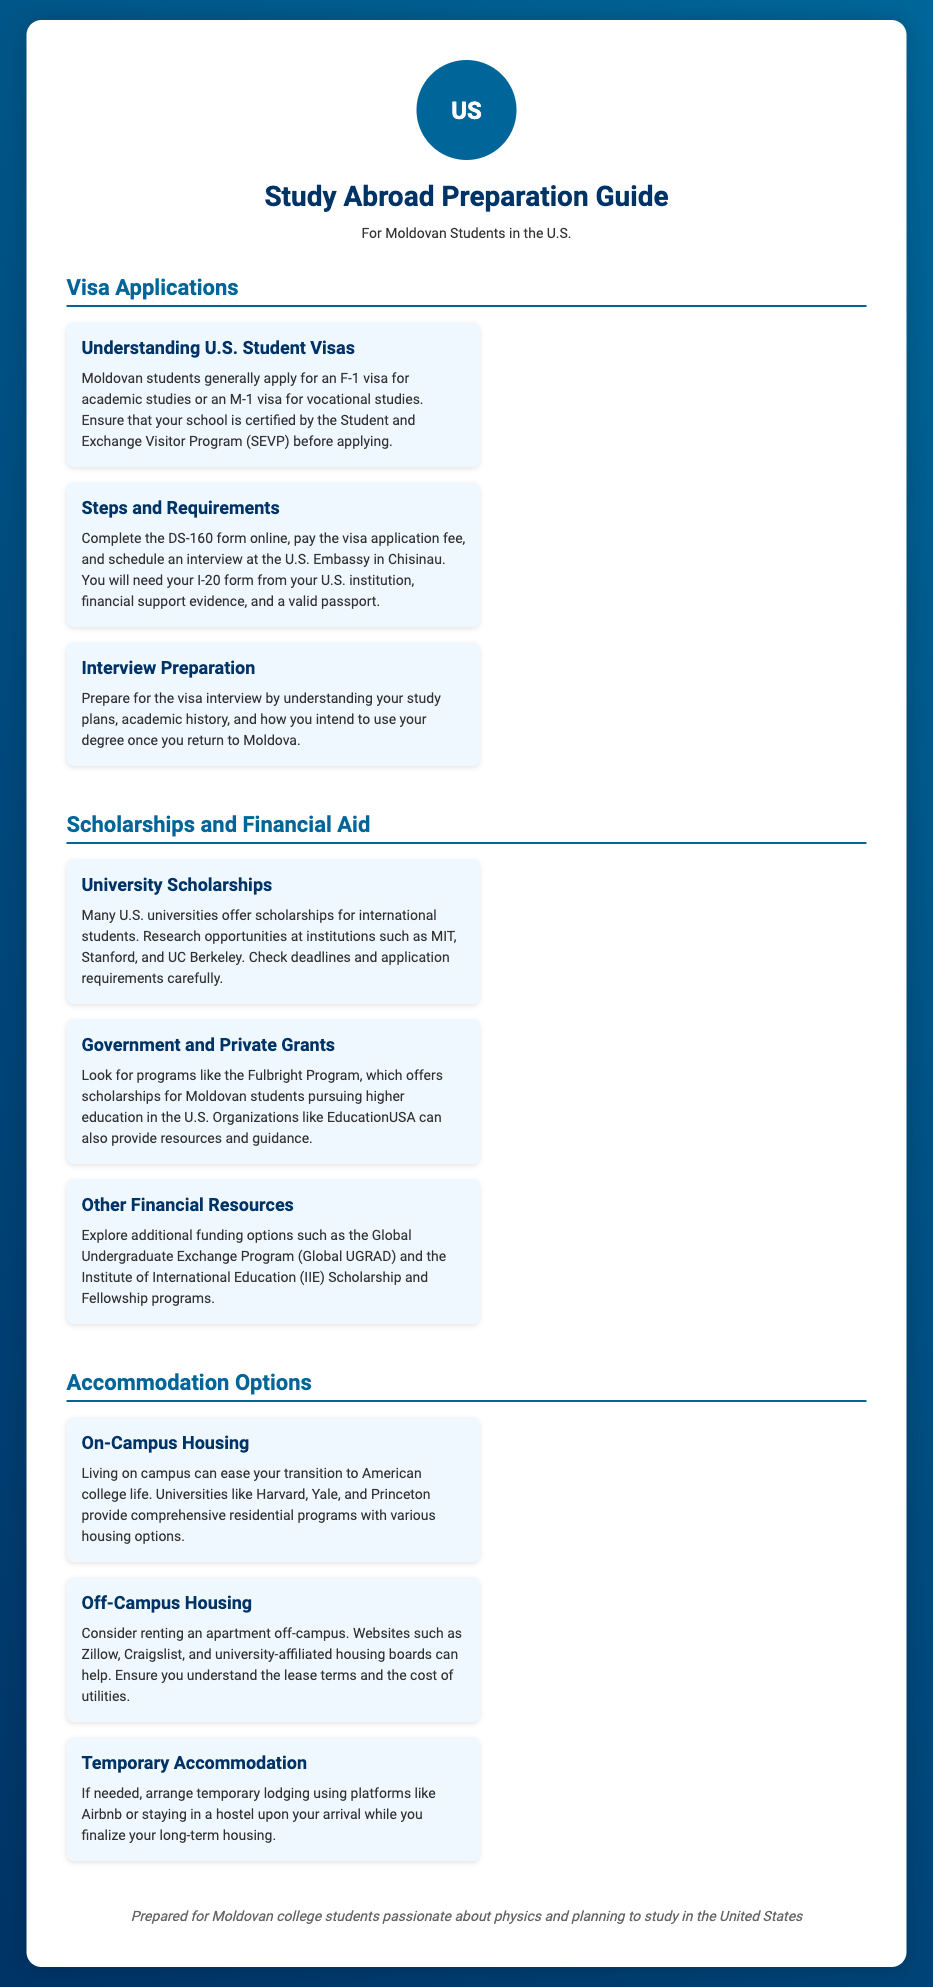what type of visa do Moldovan students generally apply for? The document states that Moldovan students generally apply for an F-1 visa for academic studies or an M-1 visa for vocational studies.
Answer: F-1 or M-1 what is the DS-160 form used for? The DS-160 form is part of the steps required for applying for a U.S. student visa.
Answer: Visa application which U.S. university offers scholarships for international students? The document mentions that many U.S. universities, including MIT, Stanford, and UC Berkeley, offer scholarships for international students.
Answer: MIT, Stanford, UC Berkeley what program offers scholarships specifically for Moldovan students? The Fulbright Program is mentioned as offering scholarships for Moldovan students pursuing higher education in the U.S.
Answer: Fulbright Program what is one option for temporary accommodation mentioned in the document? The document suggests using platforms like Airbnb or staying in a hostel for temporary accommodation.
Answer: Airbnb how many housing options does Harvard provide? The document states that universities like Harvard provide various housing options but does not specify a number.
Answer: Various what is the purpose of the seal at the top of the document? The seal symbolizes the United States and represents the context of the document focused on American educational opportunities.
Answer: Symbolizes the U.S what is the main target audience of this preparation guide? The guide is prepared for Moldovan college students passionate about physics and planning to study in the United States.
Answer: Moldovan college students 